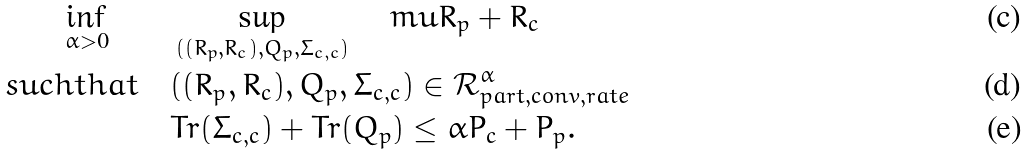Convert formula to latex. <formula><loc_0><loc_0><loc_500><loc_500>\inf _ { \alpha > 0 } \quad & \quad \sup _ { ( ( R _ { p } , R _ { c } ) , Q _ { p } , \Sigma _ { c , c } ) } \ \ \ m u R _ { p } + R _ { c } \\ s u c h t h a t & \quad ( ( R _ { p } , R _ { c } ) , Q _ { p } , \Sigma _ { c , c } ) \in \mathcal { R } _ { p a r t , c o n v , r a t e } ^ { \alpha } \\ & \quad T r ( \Sigma _ { c , c } ) + T r ( Q _ { p } ) \leq \alpha P _ { c } + P _ { p } .</formula> 